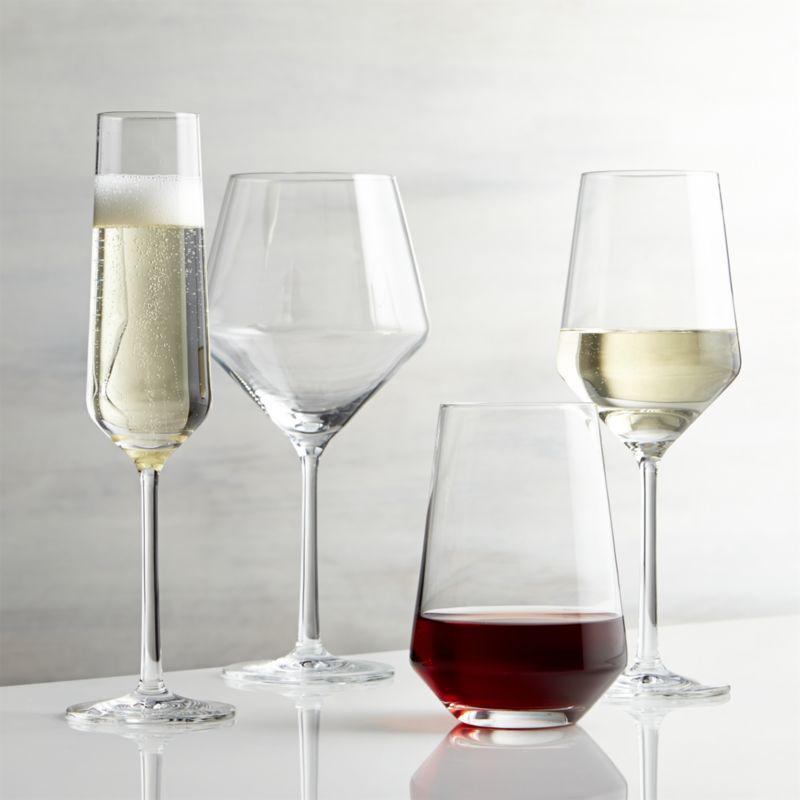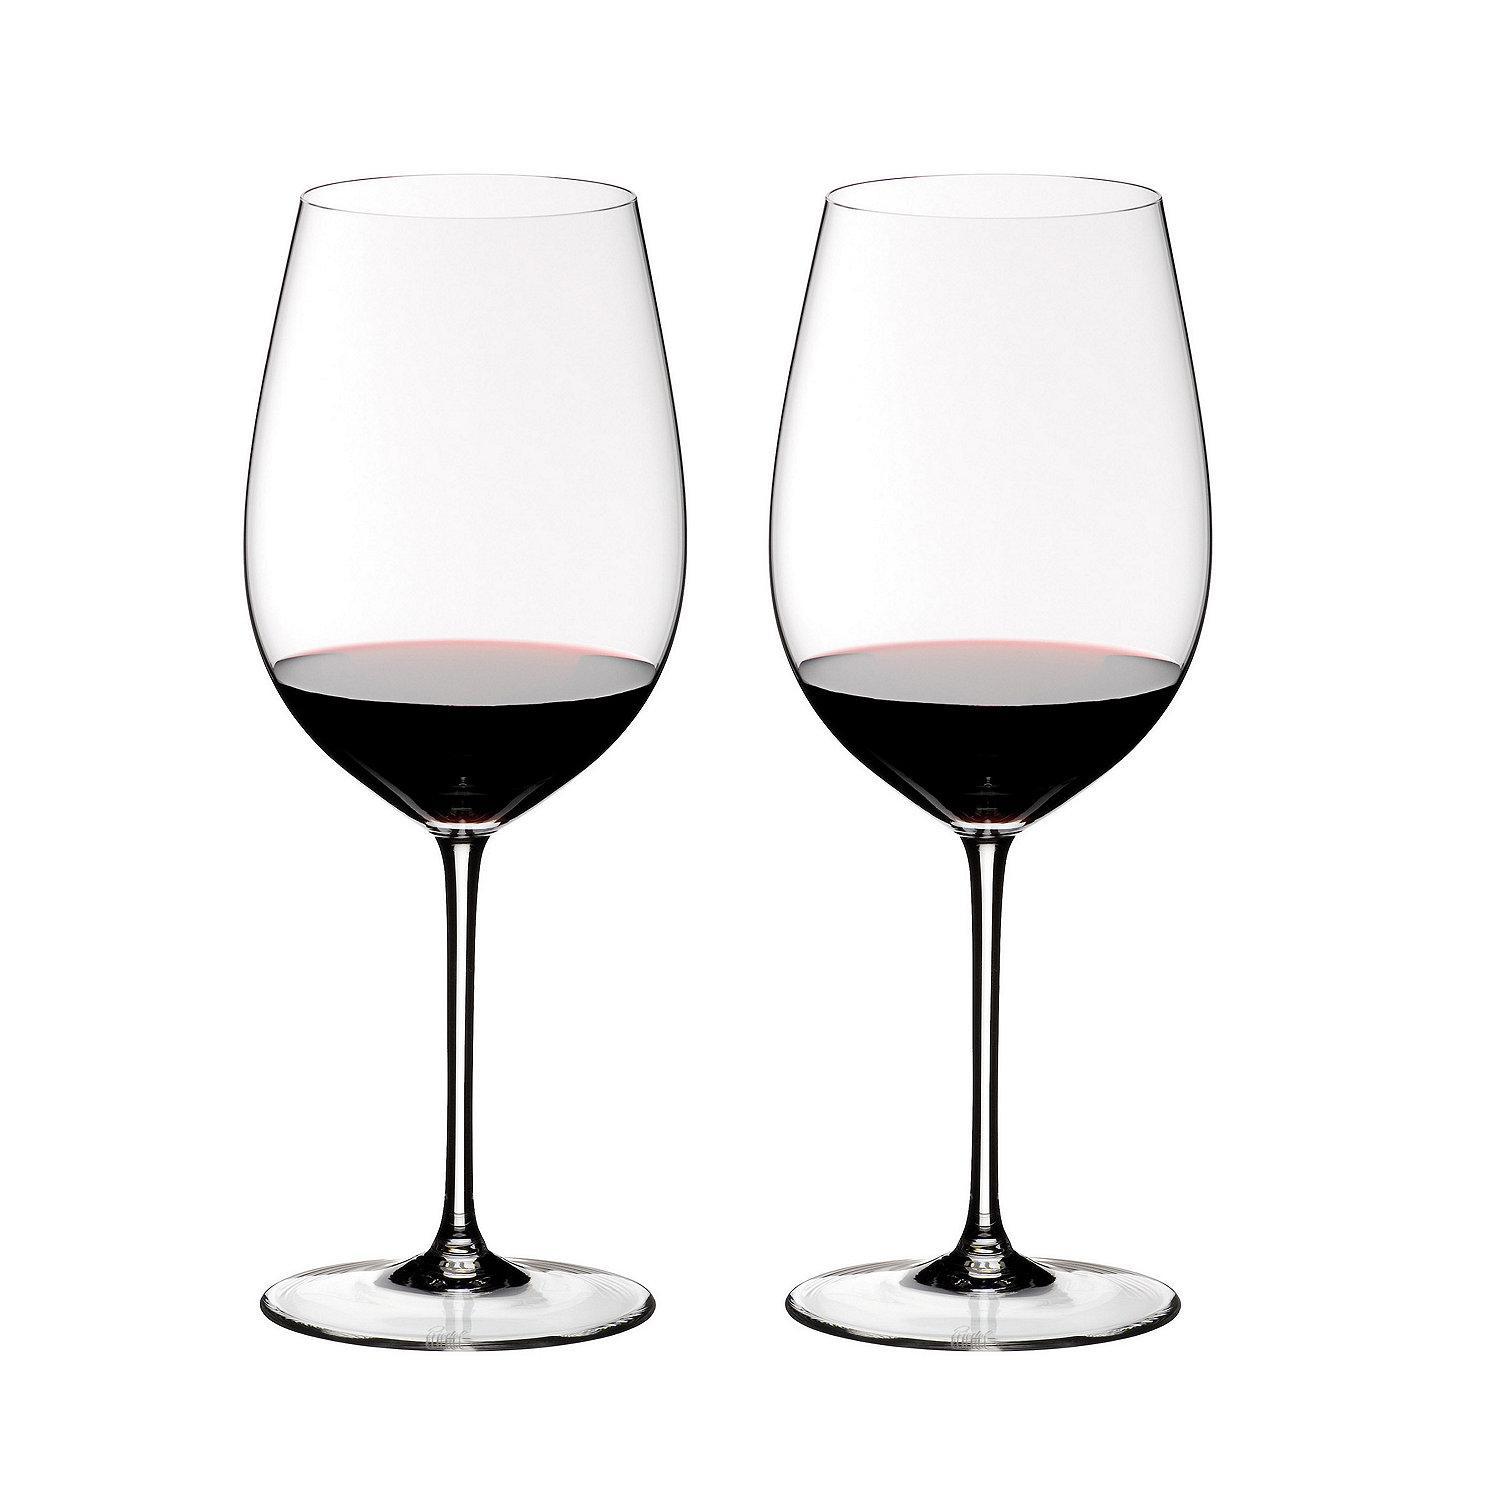The first image is the image on the left, the second image is the image on the right. Evaluate the accuracy of this statement regarding the images: "In one image, two glasses are right next to each other, and in the other, four glasses are arranged so some are in front of others.". Is it true? Answer yes or no. Yes. The first image is the image on the left, the second image is the image on the right. Given the left and right images, does the statement "In the left image, there is one glass of red wine and three empty wine glasses" hold true? Answer yes or no. No. 